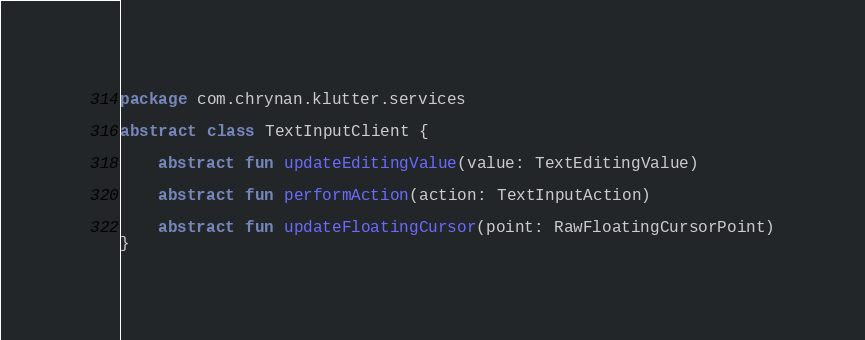<code> <loc_0><loc_0><loc_500><loc_500><_Kotlin_>package com.chrynan.klutter.services

abstract class TextInputClient {

    abstract fun updateEditingValue(value: TextEditingValue)

    abstract fun performAction(action: TextInputAction)

    abstract fun updateFloatingCursor(point: RawFloatingCursorPoint)
}</code> 